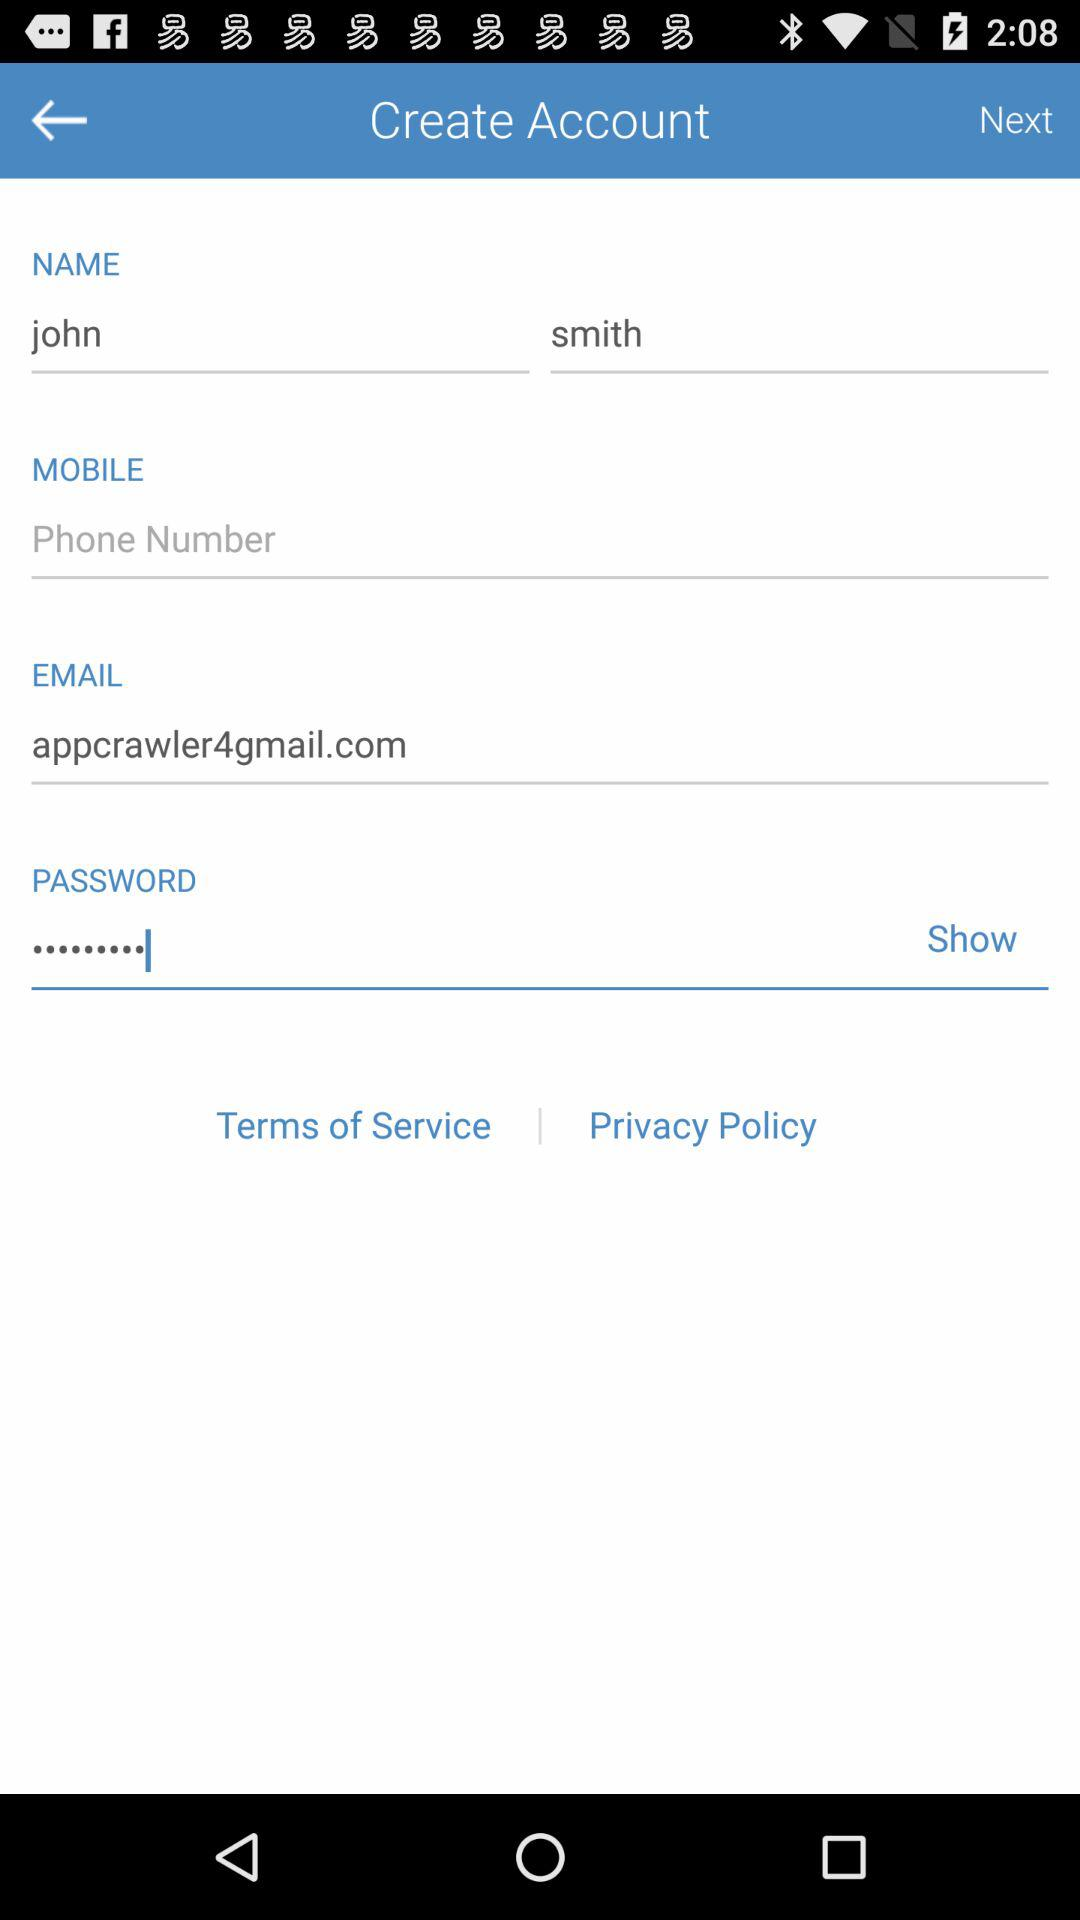What is the email address of the user? The email address is appcrawler4@gmail.com. 